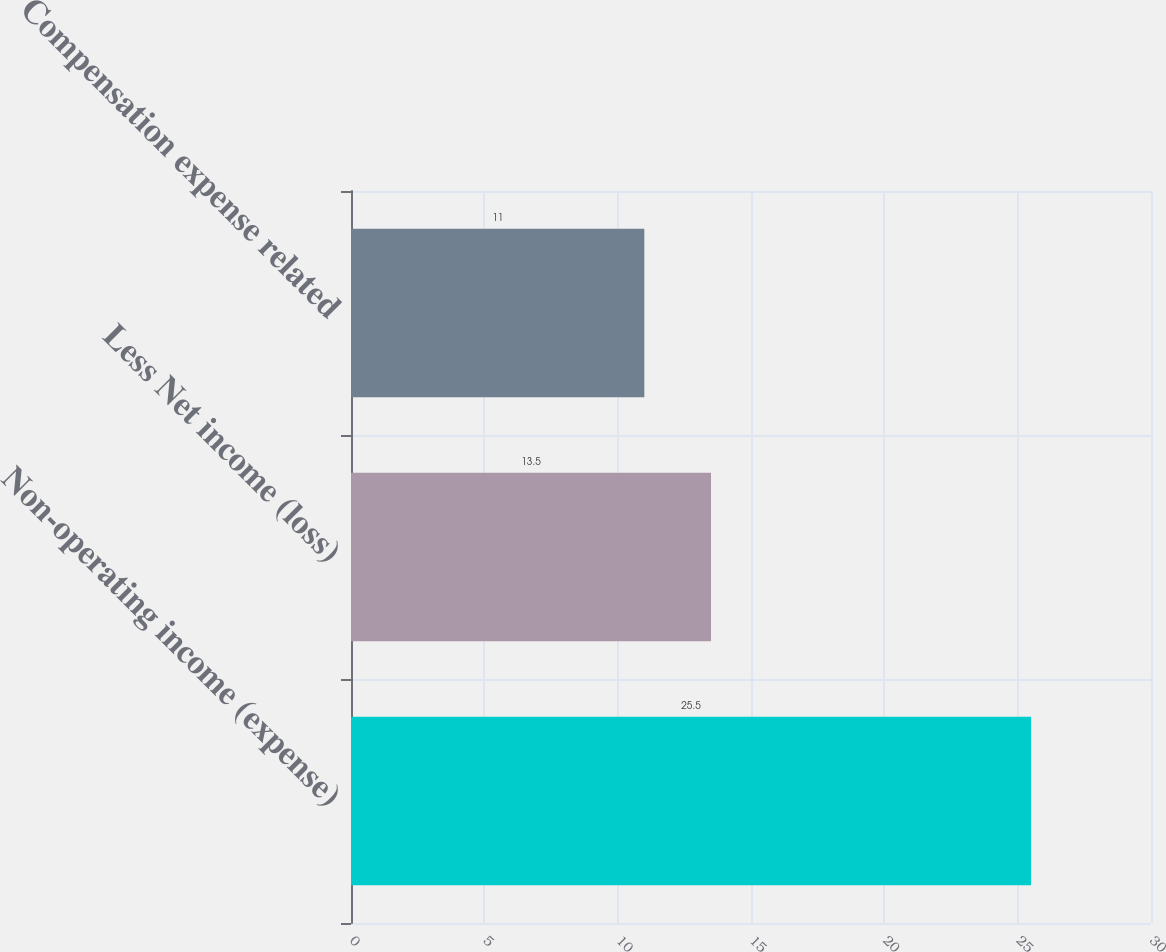Convert chart to OTSL. <chart><loc_0><loc_0><loc_500><loc_500><bar_chart><fcel>Non-operating income (expense)<fcel>Less Net income (loss)<fcel>Compensation expense related<nl><fcel>25.5<fcel>13.5<fcel>11<nl></chart> 